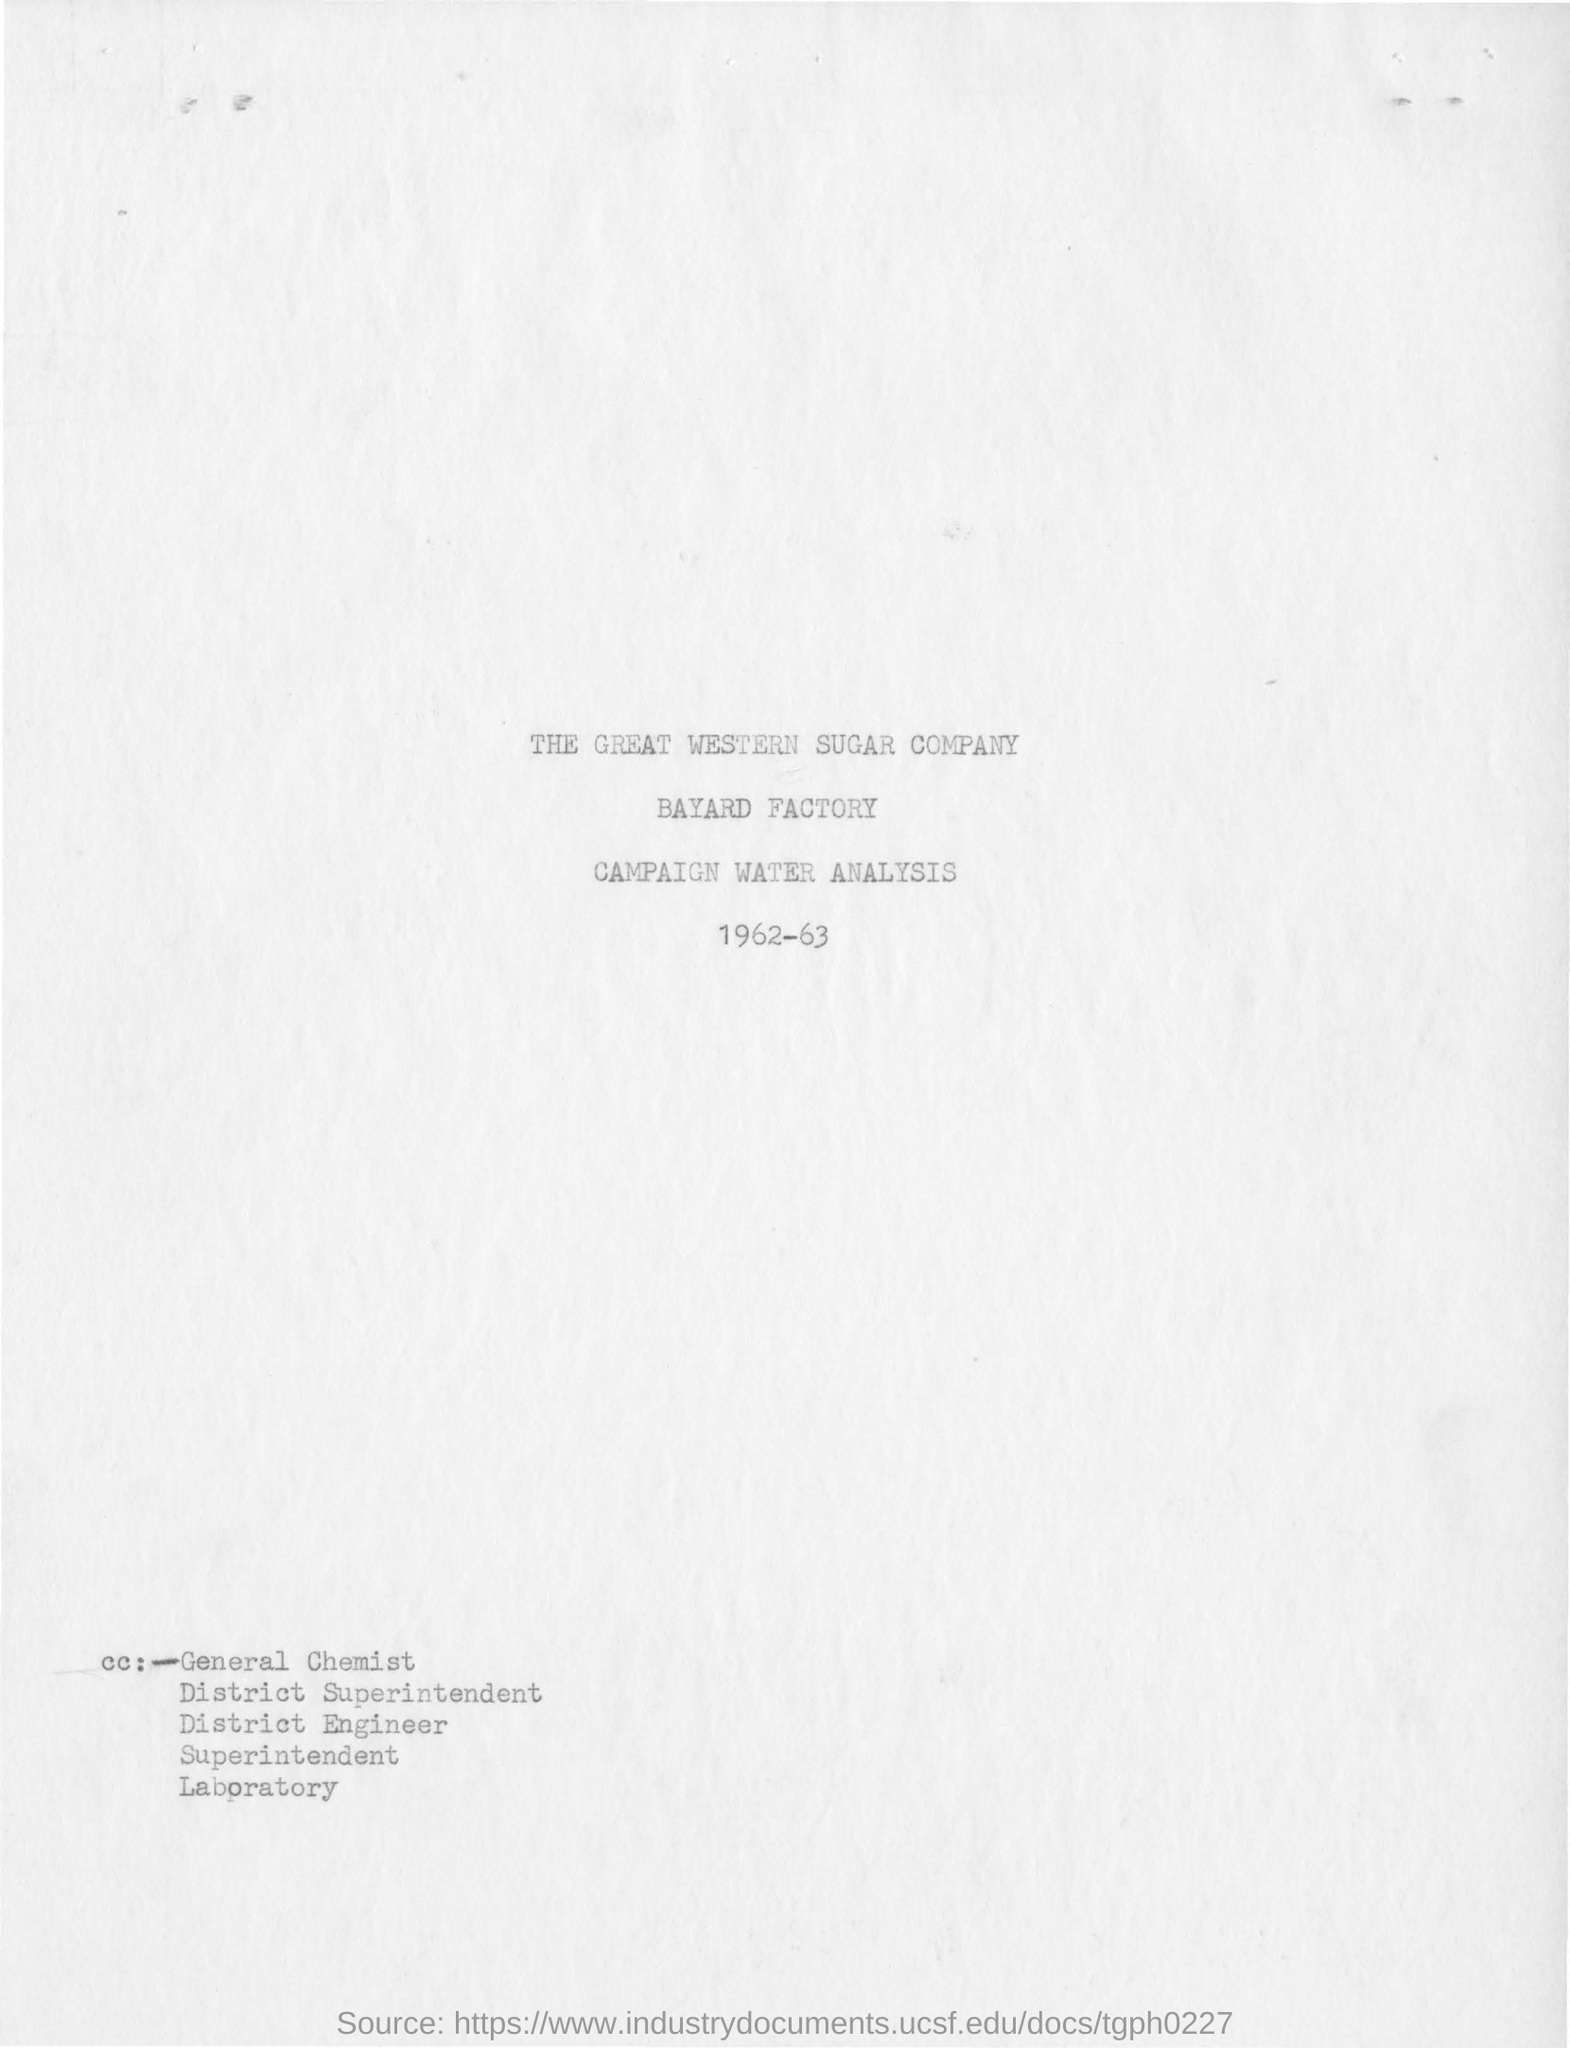Outline some significant characteristics in this image. The analysis report was created for the year 1962-63. The report mentions a factory called Bayard Factory. 